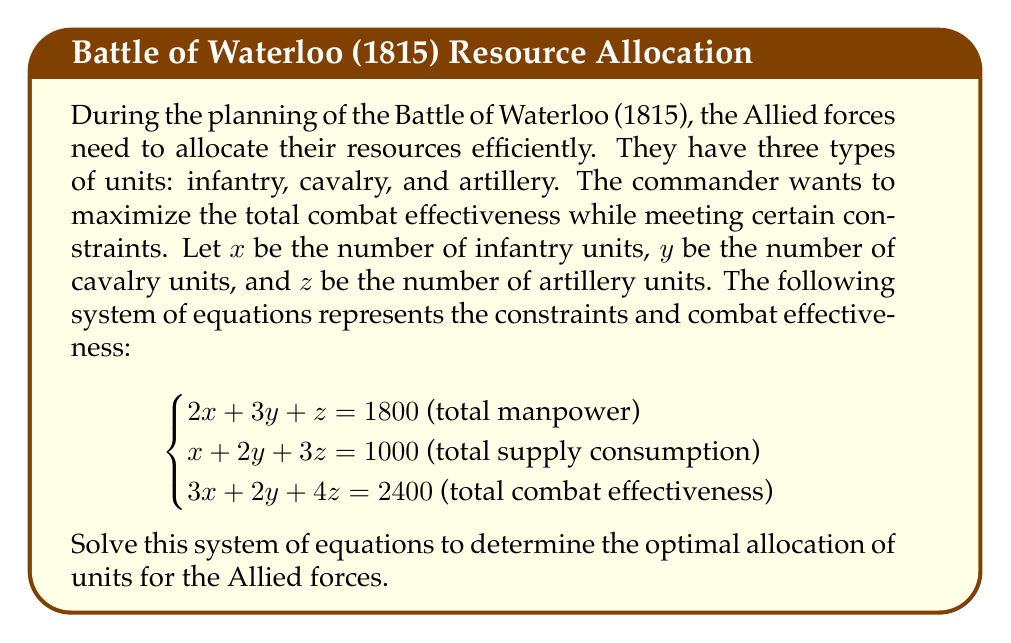What is the answer to this math problem? To solve this system of equations, we'll use the Gaussian elimination method:

1) First, let's write the augmented matrix:

   $$\begin{bmatrix}
   2 & 3 & 1 & 1800 \\
   1 & 2 & 3 & 1000 \\
   3 & 2 & 4 & 2400
   \end{bmatrix}$$

2) Multiply the first row by -1/2 and add it to the second row:

   $$\begin{bmatrix}
   2 & 3 & 1 & 1800 \\
   0 & 1/2 & 5/2 & 100 \\
   3 & 2 & 4 & 2400
   \end{bmatrix}$$

3) Multiply the first row by -3/2 and add it to the third row:

   $$\begin{bmatrix}
   2 & 3 & 1 & 1800 \\
   0 & 1/2 & 5/2 & 100 \\
   0 & -5/2 & 5/2 & 300
   \end{bmatrix}$$

4) Multiply the second row by 5 and add it to the third row:

   $$\begin{bmatrix}
   2 & 3 & 1 & 1800 \\
   0 & 1/2 & 5/2 & 100 \\
   0 & 0 & 15 & 800
   \end{bmatrix}$$

5) Now we have an upper triangular matrix. Let's solve for z:

   $15z = 800$
   $z = 800/15 \approx 53.33$

6) Substitute this value in the second equation:

   $1/2y + 5/2(53.33) = 100$
   $1/2y + 133.33 = 100$
   $1/2y = -33.33$
   $y = -66.66$

7) Finally, substitute these values in the first equation:

   $2x + 3(-66.66) + 53.33 = 1800$
   $2x - 200 + 53.33 = 1800$
   $2x = 1946.67$
   $x = 973.33$

8) Since we can't have fractional units, we'll round to the nearest whole number:

   $x = 973$ (infantry units)
   $y = -67$ (cavalry units)
   $z = 53$ (artillery units)

However, we can't have negative cavalry units. This suggests that the original constraints may be unrealistic or contradictory for a real-world scenario. In a practical military situation, the commander would need to adjust the constraints or consider alternative strategies.
Answer: The system of equations yields an unrealistic solution: 973 infantry units, -67 cavalry units, and 53 artillery units. This indicates that the given constraints are not feasible for a real-world military allocation problem. 